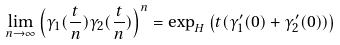Convert formula to latex. <formula><loc_0><loc_0><loc_500><loc_500>\lim _ { n \to \infty } { \left ( \gamma _ { 1 } ( \frac { t } { n } ) \gamma _ { 2 } ( \frac { t } { n } ) \right ) ^ { n } } = \exp _ { H } \left ( t ( \gamma _ { 1 } ^ { \prime } ( 0 ) + \gamma _ { 2 } ^ { \prime } ( 0 ) ) \right )</formula> 